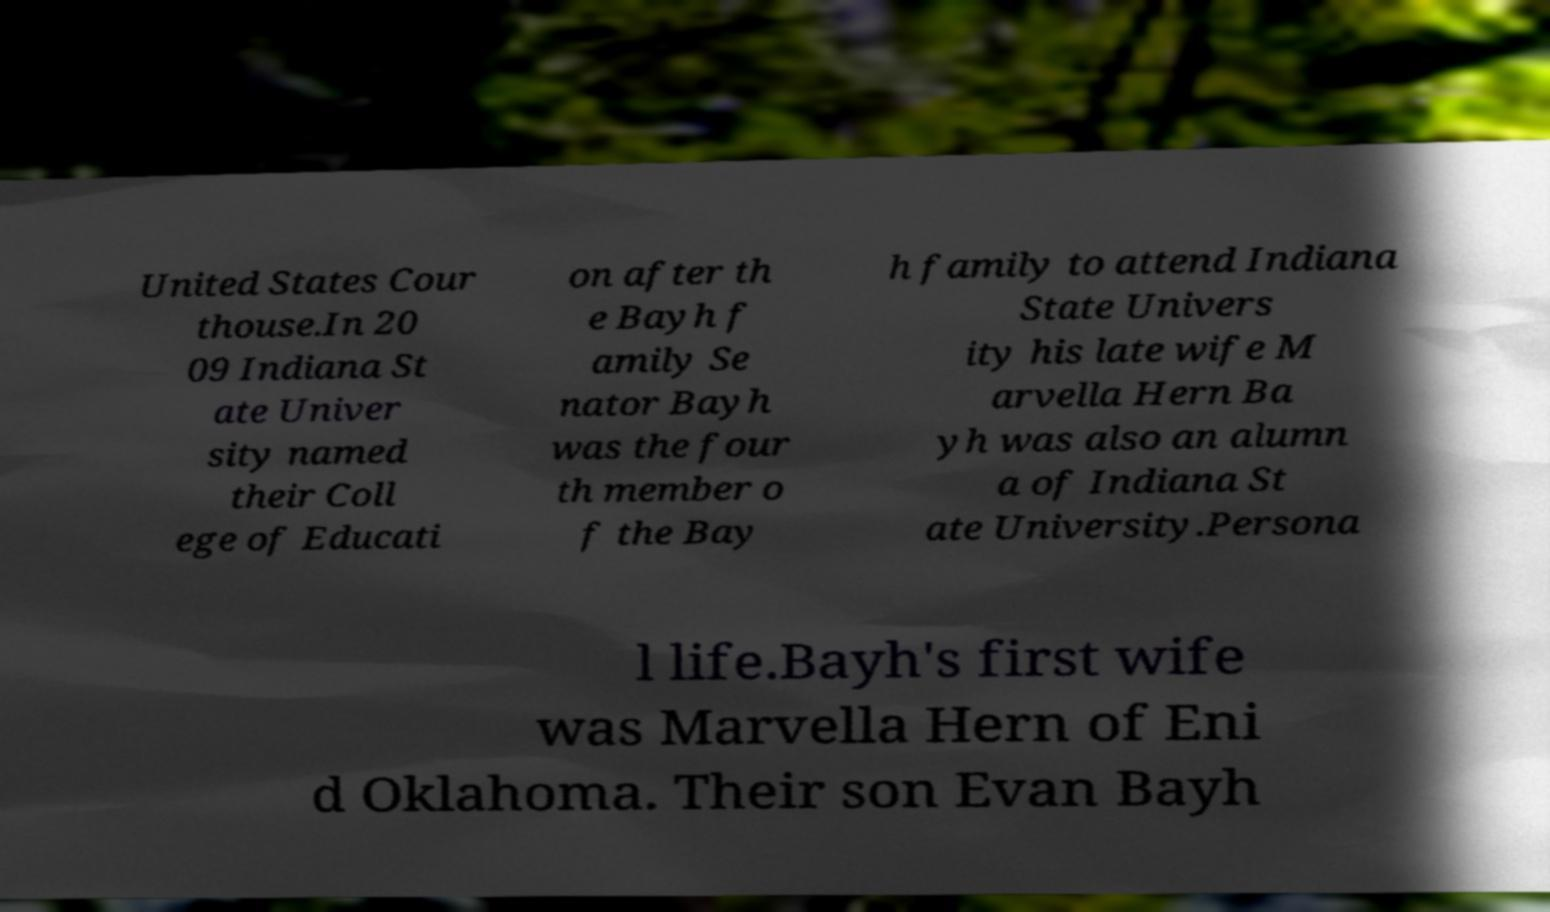Can you read and provide the text displayed in the image?This photo seems to have some interesting text. Can you extract and type it out for me? United States Cour thouse.In 20 09 Indiana St ate Univer sity named their Coll ege of Educati on after th e Bayh f amily Se nator Bayh was the four th member o f the Bay h family to attend Indiana State Univers ity his late wife M arvella Hern Ba yh was also an alumn a of Indiana St ate University.Persona l life.Bayh's first wife was Marvella Hern of Eni d Oklahoma. Their son Evan Bayh 